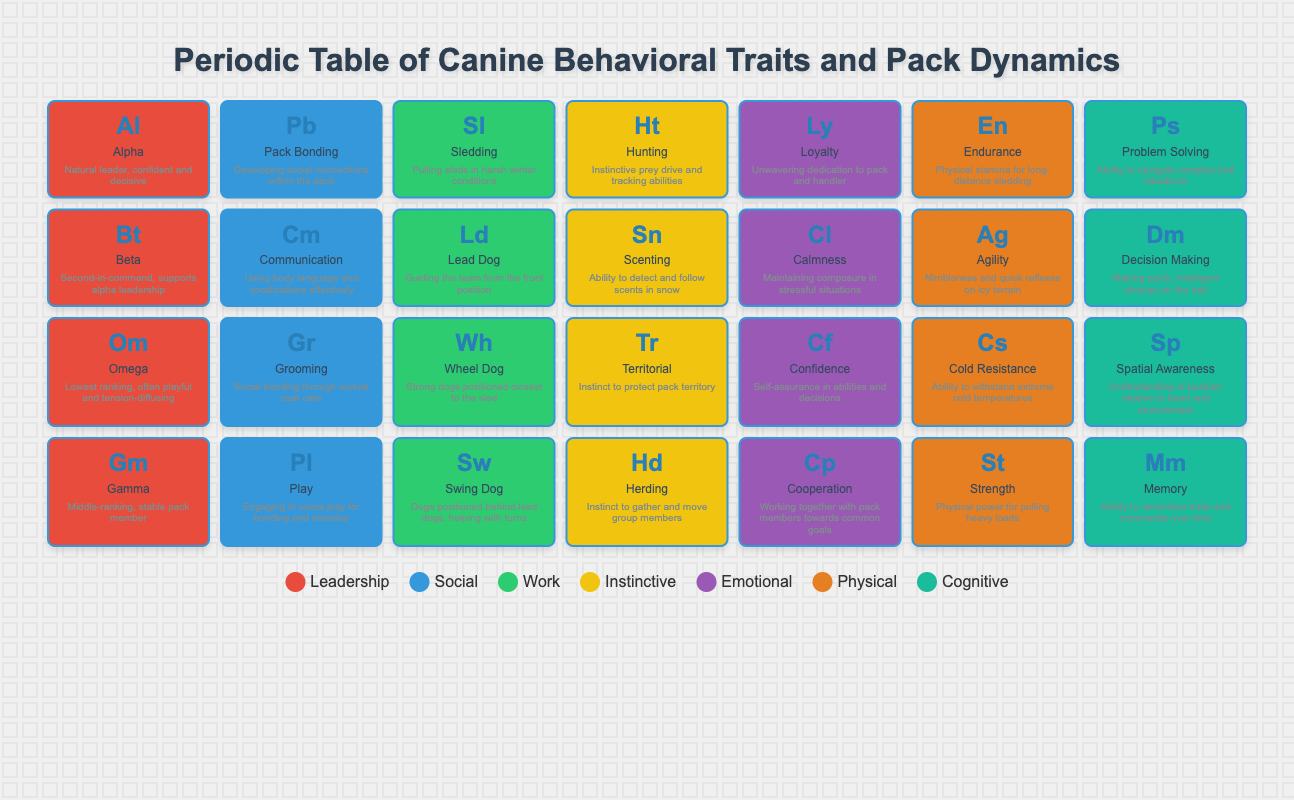What is the description of the element with the symbol "Al"? Referring to the corresponding section in the table for the element with the symbol "Al," which stands for "Alpha," the description states, "Natural leader, confident and decisive."
Answer: Natural leader, confident and decisive Which group includes the trait "Endurance"? By looking at the table, "Endurance" is listed under the group identified as number 5, corresponding to the "Physical" category.
Answer: Physical How many traits belong to the "Social" group? The "Social" group corresponds to group number 1. By counting the elements in this group from the table, there are four traits: "Pack Bonding," "Communication," "Grooming," and "Play." Thus, 4 traits belong to the "Social" group.
Answer: 4 Does the "Beta" trait belong to the "Leadership" group? According to the table, "Beta" is categorized under group number 0, which is identified as "Leadership." Therefore, the statement is true.
Answer: Yes What is the total number of elements related to "Instinctive" behaviors? The "Instinctive" group corresponds to group number 3. By reviewing the table, the elements in this group are "Hunting," "Scenting," "Territorial," and "Herding." Hence, there are a total of 4 elements in the "Instinctive" group.
Answer: 4 Which element has the highest hierarchical rank: "Omega," "Alpha," or "Beta"? The ranking is based on the definitions: "Alpha" is the leader, "Beta" supports the Alpha, and "Omega" is the lowest-ranking member. Therefore, "Alpha" has the highest rank, followed by "Beta," with "Omega" last.
Answer: Alpha Which trait shows the ability to make quick decisions while on a trail? In the table, "Decision Making" is explicitly mentioned, and it is defined as "Making quick, intelligent choices on the trail," thus directly answering the question.
Answer: Decision Making What is the difference in the number of elements between the "Emotional" group and the "Leadership" group? The "Emotional" group corresponds to group number 4, and it includes three elements: "Loyalty," "Calmness," and "Confidence." The "Leadership" group corresponds to group number 0, which contains three elements: "Alpha," "Beta," and "Omega." Therefore, the difference is 3 (Emotional) - 3 (Leadership) = 0.
Answer: 0 What trait can be associated with the ability to withstand extreme cold temperatures? The table indicates that "Cold Resistance" is linked to the ability to withstand extreme cold temperatures. Hence, this is the trait associated with that ability.
Answer: Cold Resistance 